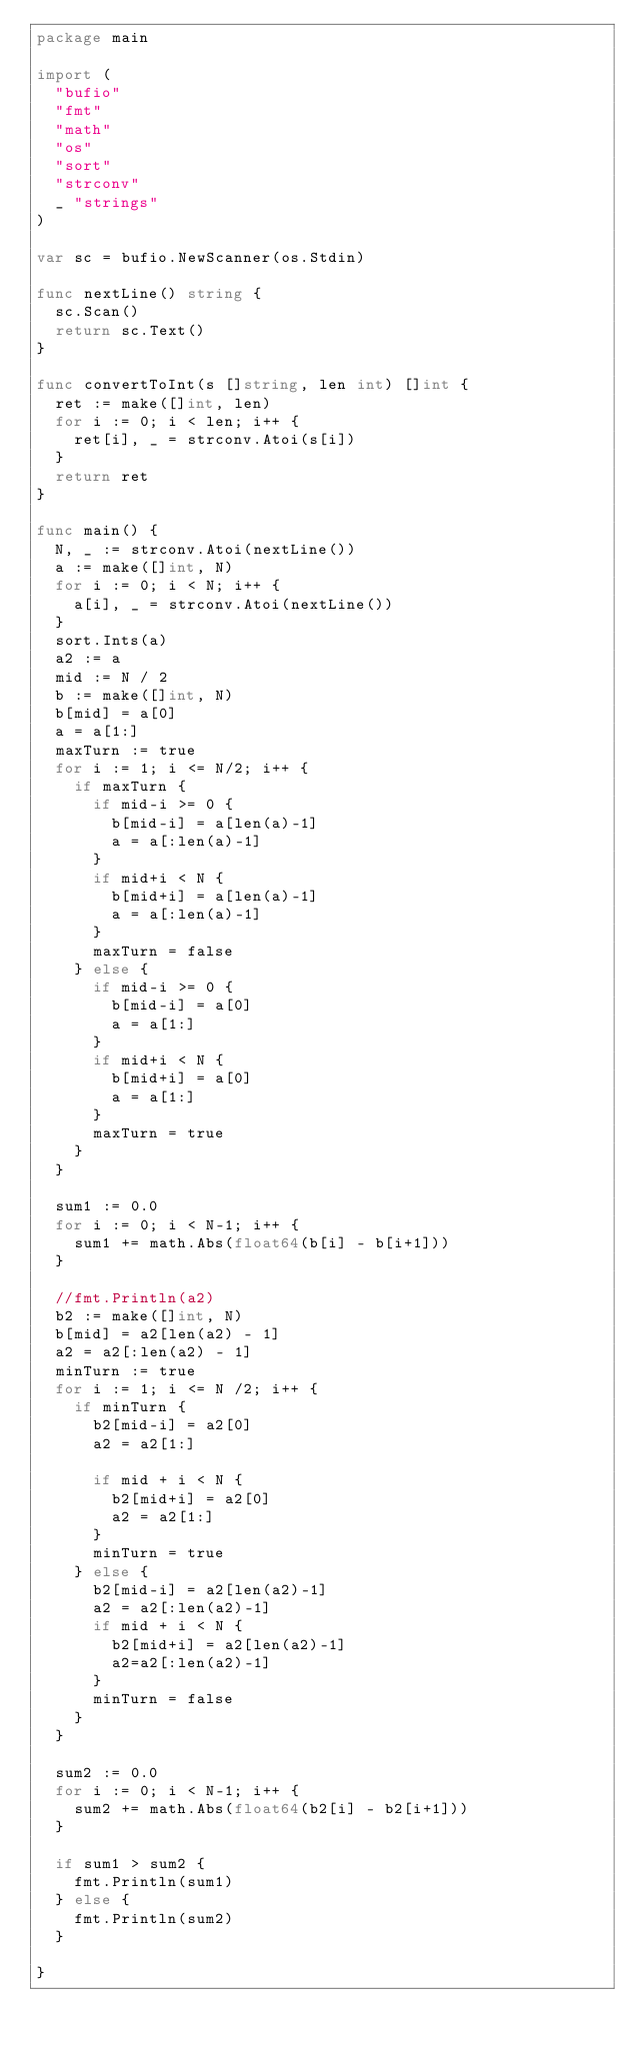<code> <loc_0><loc_0><loc_500><loc_500><_Go_>package main

import (
	"bufio"
	"fmt"
	"math"
	"os"
	"sort"
	"strconv"
	_ "strings"
)

var sc = bufio.NewScanner(os.Stdin)

func nextLine() string {
	sc.Scan()
	return sc.Text()
}

func convertToInt(s []string, len int) []int {
	ret := make([]int, len)
	for i := 0; i < len; i++ {
		ret[i], _ = strconv.Atoi(s[i])
	}
	return ret
}

func main() {
	N, _ := strconv.Atoi(nextLine())
	a := make([]int, N)
	for i := 0; i < N; i++ {
		a[i], _ = strconv.Atoi(nextLine())
	}
	sort.Ints(a)
	a2 := a
	mid := N / 2
	b := make([]int, N)
	b[mid] = a[0]
	a = a[1:]
	maxTurn := true
	for i := 1; i <= N/2; i++ {
		if maxTurn {
			if mid-i >= 0 {
				b[mid-i] = a[len(a)-1]
				a = a[:len(a)-1]
			}
			if mid+i < N {
				b[mid+i] = a[len(a)-1]
				a = a[:len(a)-1]
			}
			maxTurn = false
		} else {
			if mid-i >= 0 {
				b[mid-i] = a[0]
				a = a[1:]
			}
			if mid+i < N {
				b[mid+i] = a[0]
				a = a[1:]
			}
			maxTurn = true
		}
	}

	sum1 := 0.0
	for i := 0; i < N-1; i++ {
		sum1 += math.Abs(float64(b[i] - b[i+1]))
	}

	//fmt.Println(a2)
	b2 := make([]int, N)
	b[mid] = a2[len(a2) - 1]
	a2 = a2[:len(a2) - 1]
	minTurn := true
	for i := 1; i <= N /2; i++ {
		if minTurn {
			b2[mid-i] = a2[0]
			a2 = a2[1:]

			if mid + i < N {
				b2[mid+i] = a2[0]
				a2 = a2[1:]
			}
			minTurn = true
		} else {
			b2[mid-i] = a2[len(a2)-1]
			a2 = a2[:len(a2)-1]
			if mid + i < N {
				b2[mid+i] = a2[len(a2)-1]
				a2=a2[:len(a2)-1]
			}
			minTurn = false
		}
	}

	sum2 := 0.0
	for i := 0; i < N-1; i++ {
		sum2 += math.Abs(float64(b2[i] - b2[i+1]))
	}

	if sum1 > sum2 {
		fmt.Println(sum1)
	} else {
		fmt.Println(sum2)
	}

}</code> 